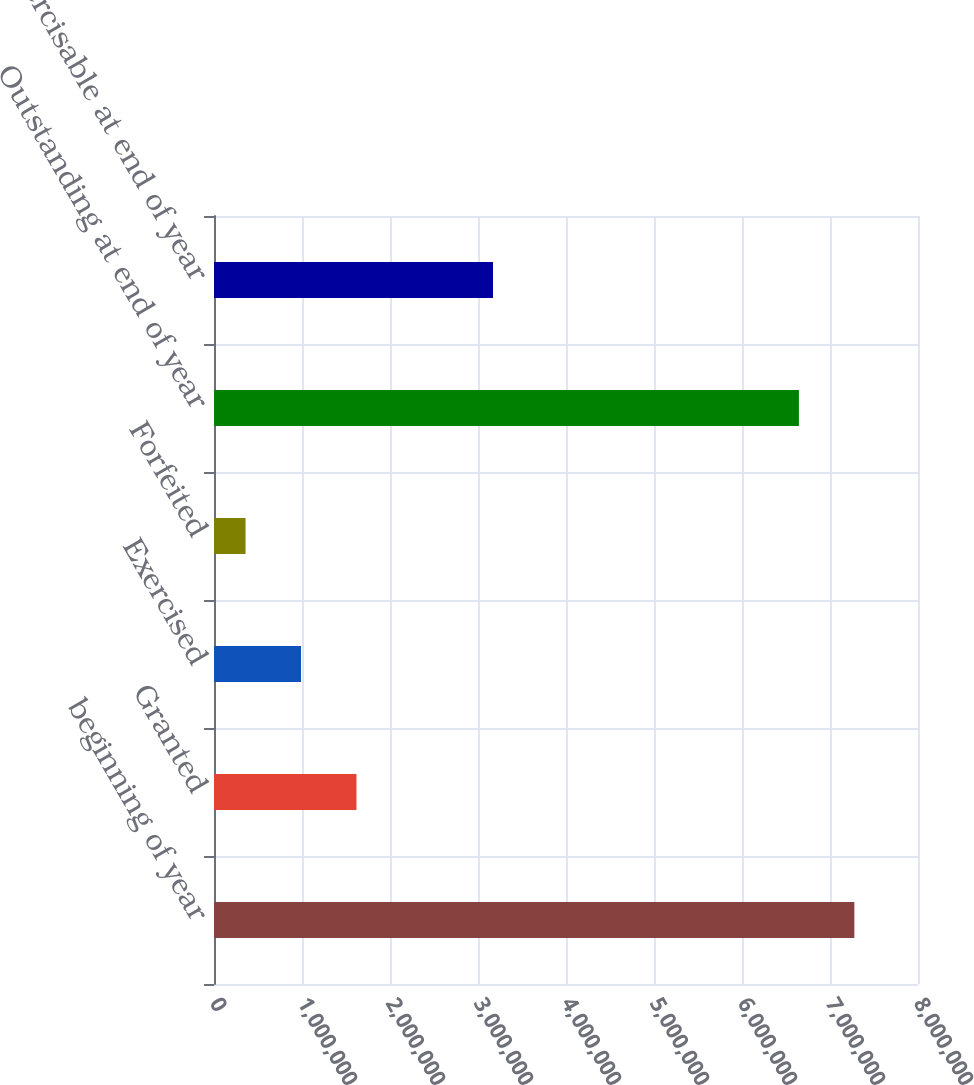Convert chart to OTSL. <chart><loc_0><loc_0><loc_500><loc_500><bar_chart><fcel>beginning of year<fcel>Granted<fcel>Exercised<fcel>Forfeited<fcel>Outstanding at end of year<fcel>Exercisable at end of year<nl><fcel>7.27689e+06<fcel>1.61891e+06<fcel>988783<fcel>358651<fcel>6.64676e+06<fcel>3.17031e+06<nl></chart> 